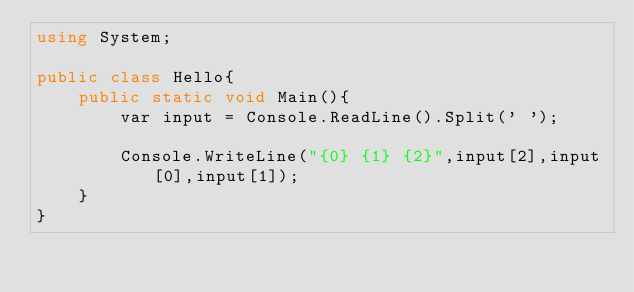<code> <loc_0><loc_0><loc_500><loc_500><_C#_>using System;

public class Hello{
    public static void Main(){
        var input = Console.ReadLine().Split(' ');
        
        Console.WriteLine("{0} {1} {2}",input[2],input[0],input[1]);
    }
}</code> 